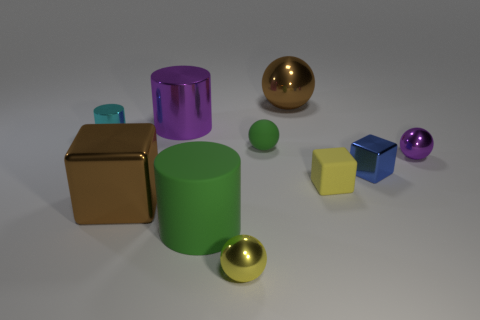Subtract all cyan cylinders. Subtract all purple blocks. How many cylinders are left? 2 Subtract all cylinders. How many objects are left? 7 Add 4 tiny rubber balls. How many tiny rubber balls exist? 5 Subtract 0 red spheres. How many objects are left? 10 Subtract all big gray blocks. Subtract all green matte spheres. How many objects are left? 9 Add 4 large green matte cylinders. How many large green matte cylinders are left? 5 